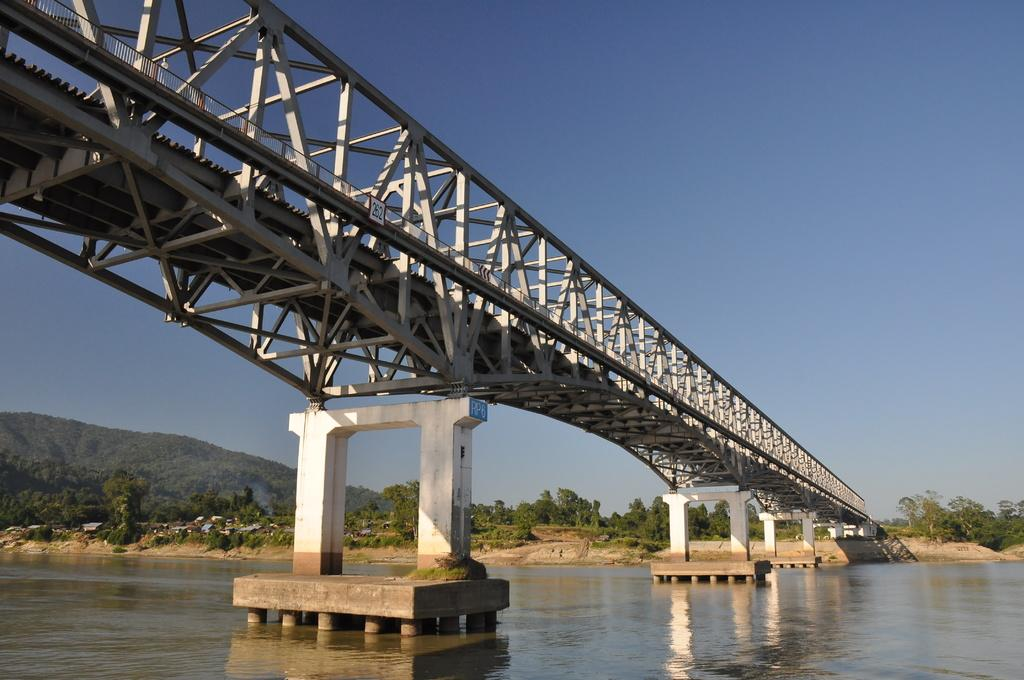What is the main structure visible in the foreground of the image? There is a bridge in the foreground of the image. What is happening under the bridge? Water is flowing under the bridge. What type of vegetation can be seen in the background of the image? There are trees in the background of the image. What natural feature is visible in the background of the image? There is a mountain in the background of the image. What part of the sky is visible in the image? The sky is visible in the background of the image. What type of list can be seen hanging from the bridge in the image? There is no list present in the image; it features a bridge with water flowing underneath and a background with trees, a mountain, and the sky. Can you hear the people in the image laughing while looking at the bridge? There is no indication of people or laughter in the image, as it only shows a bridge, water, trees, a mountain, and the sky. 